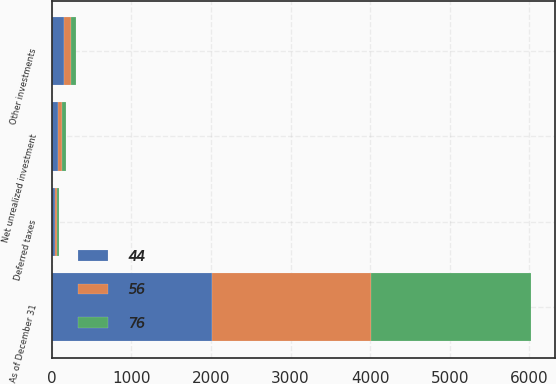Convert chart. <chart><loc_0><loc_0><loc_500><loc_500><stacked_bar_chart><ecel><fcel>As of December 31<fcel>Other investments<fcel>Deferred taxes<fcel>Net unrealized investment<nl><fcel>76<fcel>2009<fcel>69<fcel>25<fcel>44<nl><fcel>56<fcel>2008<fcel>85<fcel>32<fcel>56<nl><fcel>44<fcel>2007<fcel>150<fcel>39<fcel>76<nl></chart> 